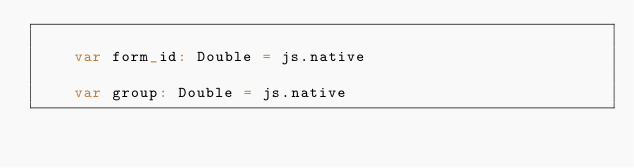Convert code to text. <code><loc_0><loc_0><loc_500><loc_500><_Scala_>    
    var form_id: Double = js.native
    
    var group: Double = js.native
    </code> 